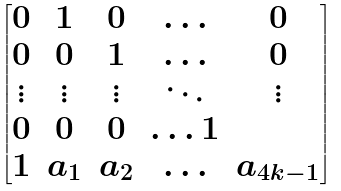Convert formula to latex. <formula><loc_0><loc_0><loc_500><loc_500>\begin{bmatrix} 0 & 1 & 0 & \hdots & 0 \\ 0 & 0 & 1 & \hdots & 0 \\ \vdots & \vdots & \vdots & \ddots & \vdots \\ 0 & 0 & 0 & \hdots 1 \\ 1 & a _ { 1 } & a _ { 2 } & \hdots & a _ { 4 k - 1 } \end{bmatrix}</formula> 